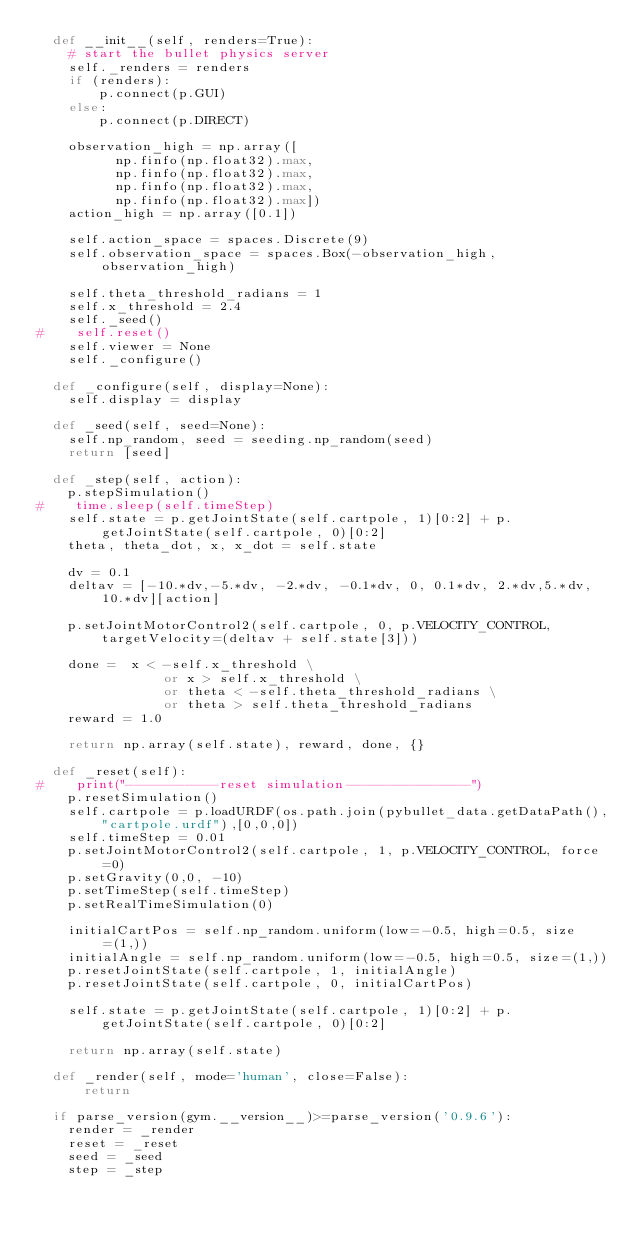Convert code to text. <code><loc_0><loc_0><loc_500><loc_500><_Python_>  def __init__(self, renders=True):
    # start the bullet physics server
    self._renders = renders
    if (renders):
	    p.connect(p.GUI)
    else:
    	p.connect(p.DIRECT)

    observation_high = np.array([
          np.finfo(np.float32).max,
          np.finfo(np.float32).max,
          np.finfo(np.float32).max,
          np.finfo(np.float32).max])
    action_high = np.array([0.1])

    self.action_space = spaces.Discrete(9)
    self.observation_space = spaces.Box(-observation_high, observation_high)

    self.theta_threshold_radians = 1
    self.x_threshold = 2.4
    self._seed()
#    self.reset()
    self.viewer = None
    self._configure()

  def _configure(self, display=None):
    self.display = display

  def _seed(self, seed=None):
    self.np_random, seed = seeding.np_random(seed)
    return [seed]

  def _step(self, action):
    p.stepSimulation()
#    time.sleep(self.timeStep)
    self.state = p.getJointState(self.cartpole, 1)[0:2] + p.getJointState(self.cartpole, 0)[0:2]
    theta, theta_dot, x, x_dot = self.state

    dv = 0.1
    deltav = [-10.*dv,-5.*dv, -2.*dv, -0.1*dv, 0, 0.1*dv, 2.*dv,5.*dv, 10.*dv][action]

    p.setJointMotorControl2(self.cartpole, 0, p.VELOCITY_CONTROL, targetVelocity=(deltav + self.state[3]))

    done =  x < -self.x_threshold \
                or x > self.x_threshold \
                or theta < -self.theta_threshold_radians \
                or theta > self.theta_threshold_radians
    reward = 1.0

    return np.array(self.state), reward, done, {}

  def _reset(self):
#    print("-----------reset simulation---------------")
    p.resetSimulation()
    self.cartpole = p.loadURDF(os.path.join(pybullet_data.getDataPath(),"cartpole.urdf"),[0,0,0])
    self.timeStep = 0.01
    p.setJointMotorControl2(self.cartpole, 1, p.VELOCITY_CONTROL, force=0)
    p.setGravity(0,0, -10)
    p.setTimeStep(self.timeStep)
    p.setRealTimeSimulation(0)

    initialCartPos = self.np_random.uniform(low=-0.5, high=0.5, size=(1,))
    initialAngle = self.np_random.uniform(low=-0.5, high=0.5, size=(1,))
    p.resetJointState(self.cartpole, 1, initialAngle)
    p.resetJointState(self.cartpole, 0, initialCartPos)

    self.state = p.getJointState(self.cartpole, 1)[0:2] + p.getJointState(self.cartpole, 0)[0:2]

    return np.array(self.state)

  def _render(self, mode='human', close=False):
      return

  if parse_version(gym.__version__)>=parse_version('0.9.6'):
    render = _render
    reset = _reset
    seed = _seed
    step = _step
</code> 